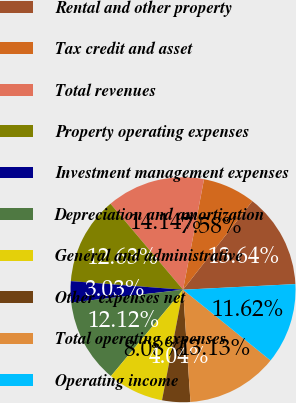<chart> <loc_0><loc_0><loc_500><loc_500><pie_chart><fcel>Rental and other property<fcel>Tax credit and asset<fcel>Total revenues<fcel>Property operating expenses<fcel>Investment management expenses<fcel>Depreciation and amortization<fcel>General and administrative<fcel>Other expenses net<fcel>Total operating expenses<fcel>Operating income<nl><fcel>13.64%<fcel>7.58%<fcel>14.14%<fcel>12.63%<fcel>3.03%<fcel>12.12%<fcel>8.08%<fcel>4.04%<fcel>13.13%<fcel>11.62%<nl></chart> 